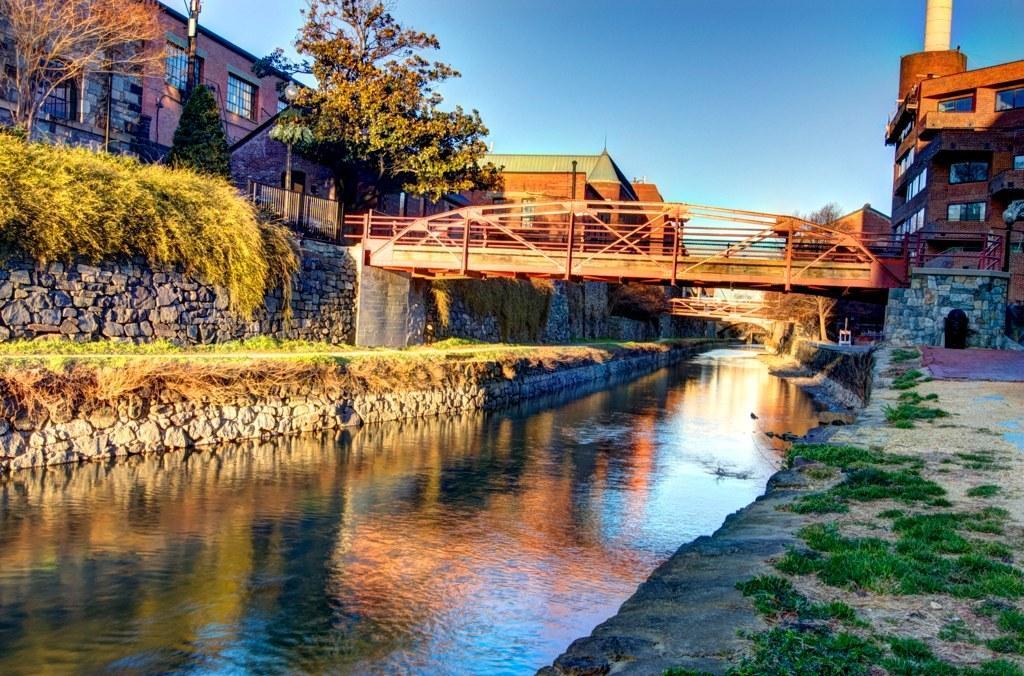Describe this image in one or two sentences. In the foreground of the picture we can see grass, canal, plants and wall. In the middle of the picture there are buildings, trees, bridges and other objects. At the top it is sky. 